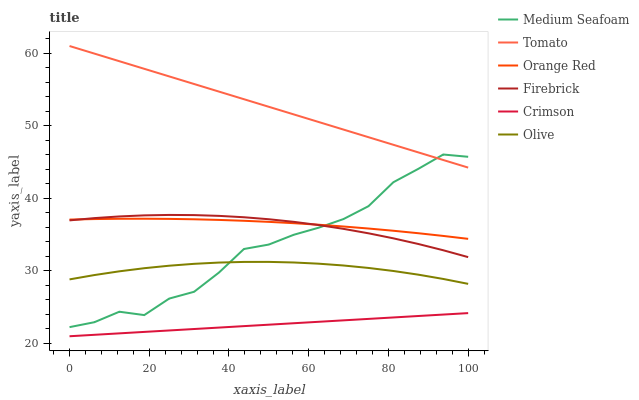Does Crimson have the minimum area under the curve?
Answer yes or no. Yes. Does Tomato have the maximum area under the curve?
Answer yes or no. Yes. Does Firebrick have the minimum area under the curve?
Answer yes or no. No. Does Firebrick have the maximum area under the curve?
Answer yes or no. No. Is Crimson the smoothest?
Answer yes or no. Yes. Is Medium Seafoam the roughest?
Answer yes or no. Yes. Is Firebrick the smoothest?
Answer yes or no. No. Is Firebrick the roughest?
Answer yes or no. No. Does Crimson have the lowest value?
Answer yes or no. Yes. Does Firebrick have the lowest value?
Answer yes or no. No. Does Tomato have the highest value?
Answer yes or no. Yes. Does Firebrick have the highest value?
Answer yes or no. No. Is Crimson less than Tomato?
Answer yes or no. Yes. Is Tomato greater than Firebrick?
Answer yes or no. Yes. Does Tomato intersect Medium Seafoam?
Answer yes or no. Yes. Is Tomato less than Medium Seafoam?
Answer yes or no. No. Is Tomato greater than Medium Seafoam?
Answer yes or no. No. Does Crimson intersect Tomato?
Answer yes or no. No. 